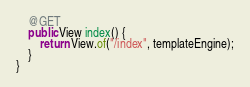<code> <loc_0><loc_0><loc_500><loc_500><_Java_>
    @GET
    public View index() {
        return View.of("/index", templateEngine);
    }
}
</code> 